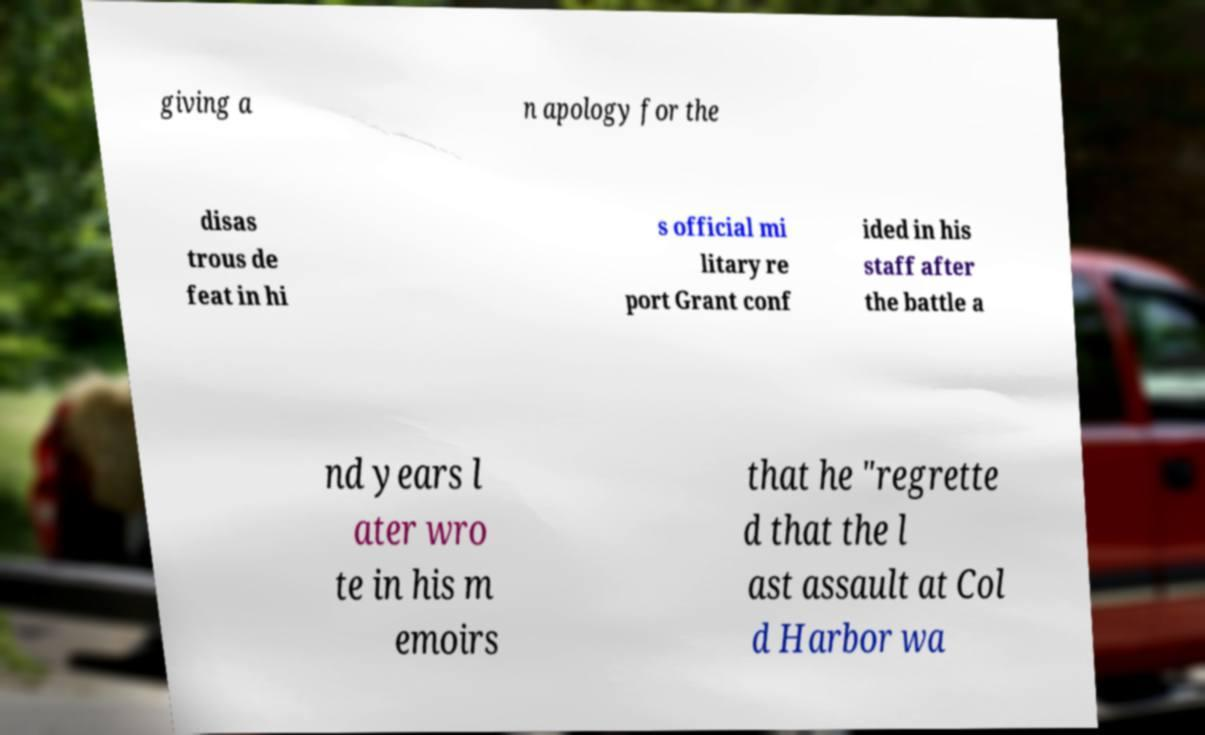Please read and relay the text visible in this image. What does it say? giving a n apology for the disas trous de feat in hi s official mi litary re port Grant conf ided in his staff after the battle a nd years l ater wro te in his m emoirs that he "regrette d that the l ast assault at Col d Harbor wa 